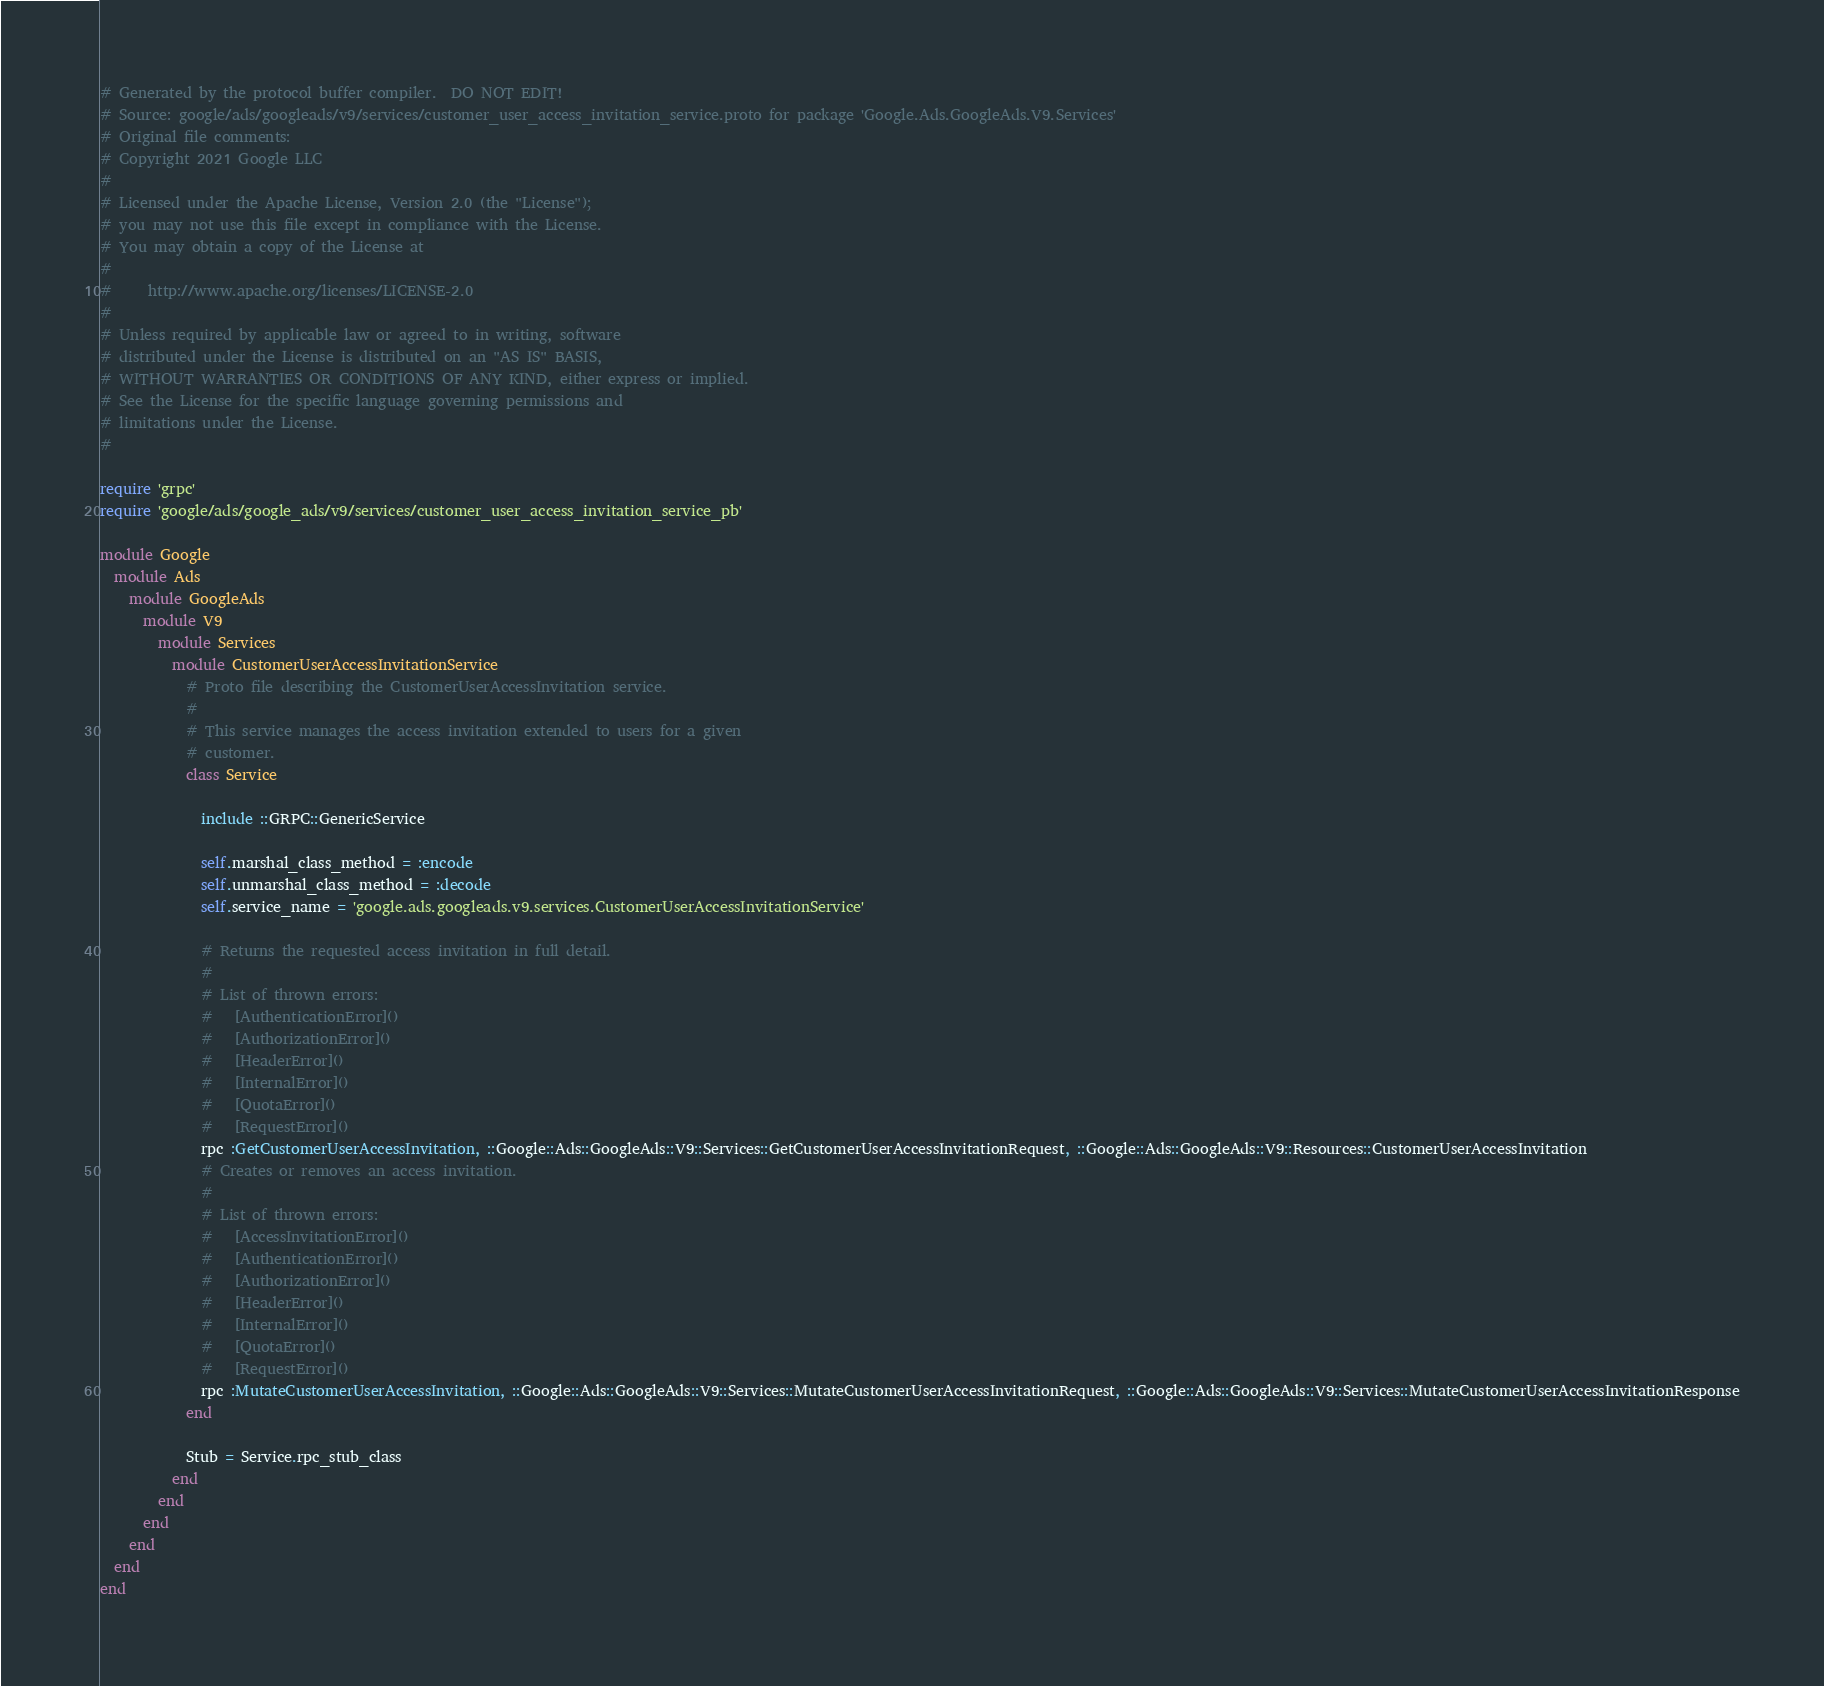<code> <loc_0><loc_0><loc_500><loc_500><_Ruby_># Generated by the protocol buffer compiler.  DO NOT EDIT!
# Source: google/ads/googleads/v9/services/customer_user_access_invitation_service.proto for package 'Google.Ads.GoogleAds.V9.Services'
# Original file comments:
# Copyright 2021 Google LLC
#
# Licensed under the Apache License, Version 2.0 (the "License");
# you may not use this file except in compliance with the License.
# You may obtain a copy of the License at
#
#     http://www.apache.org/licenses/LICENSE-2.0
#
# Unless required by applicable law or agreed to in writing, software
# distributed under the License is distributed on an "AS IS" BASIS,
# WITHOUT WARRANTIES OR CONDITIONS OF ANY KIND, either express or implied.
# See the License for the specific language governing permissions and
# limitations under the License.
#

require 'grpc'
require 'google/ads/google_ads/v9/services/customer_user_access_invitation_service_pb'

module Google
  module Ads
    module GoogleAds
      module V9
        module Services
          module CustomerUserAccessInvitationService
            # Proto file describing the CustomerUserAccessInvitation service.
            #
            # This service manages the access invitation extended to users for a given
            # customer.
            class Service

              include ::GRPC::GenericService

              self.marshal_class_method = :encode
              self.unmarshal_class_method = :decode
              self.service_name = 'google.ads.googleads.v9.services.CustomerUserAccessInvitationService'

              # Returns the requested access invitation in full detail.
              #
              # List of thrown errors:
              #   [AuthenticationError]()
              #   [AuthorizationError]()
              #   [HeaderError]()
              #   [InternalError]()
              #   [QuotaError]()
              #   [RequestError]()
              rpc :GetCustomerUserAccessInvitation, ::Google::Ads::GoogleAds::V9::Services::GetCustomerUserAccessInvitationRequest, ::Google::Ads::GoogleAds::V9::Resources::CustomerUserAccessInvitation
              # Creates or removes an access invitation.
              #
              # List of thrown errors:
              #   [AccessInvitationError]()
              #   [AuthenticationError]()
              #   [AuthorizationError]()
              #   [HeaderError]()
              #   [InternalError]()
              #   [QuotaError]()
              #   [RequestError]()
              rpc :MutateCustomerUserAccessInvitation, ::Google::Ads::GoogleAds::V9::Services::MutateCustomerUserAccessInvitationRequest, ::Google::Ads::GoogleAds::V9::Services::MutateCustomerUserAccessInvitationResponse
            end

            Stub = Service.rpc_stub_class
          end
        end
      end
    end
  end
end
</code> 